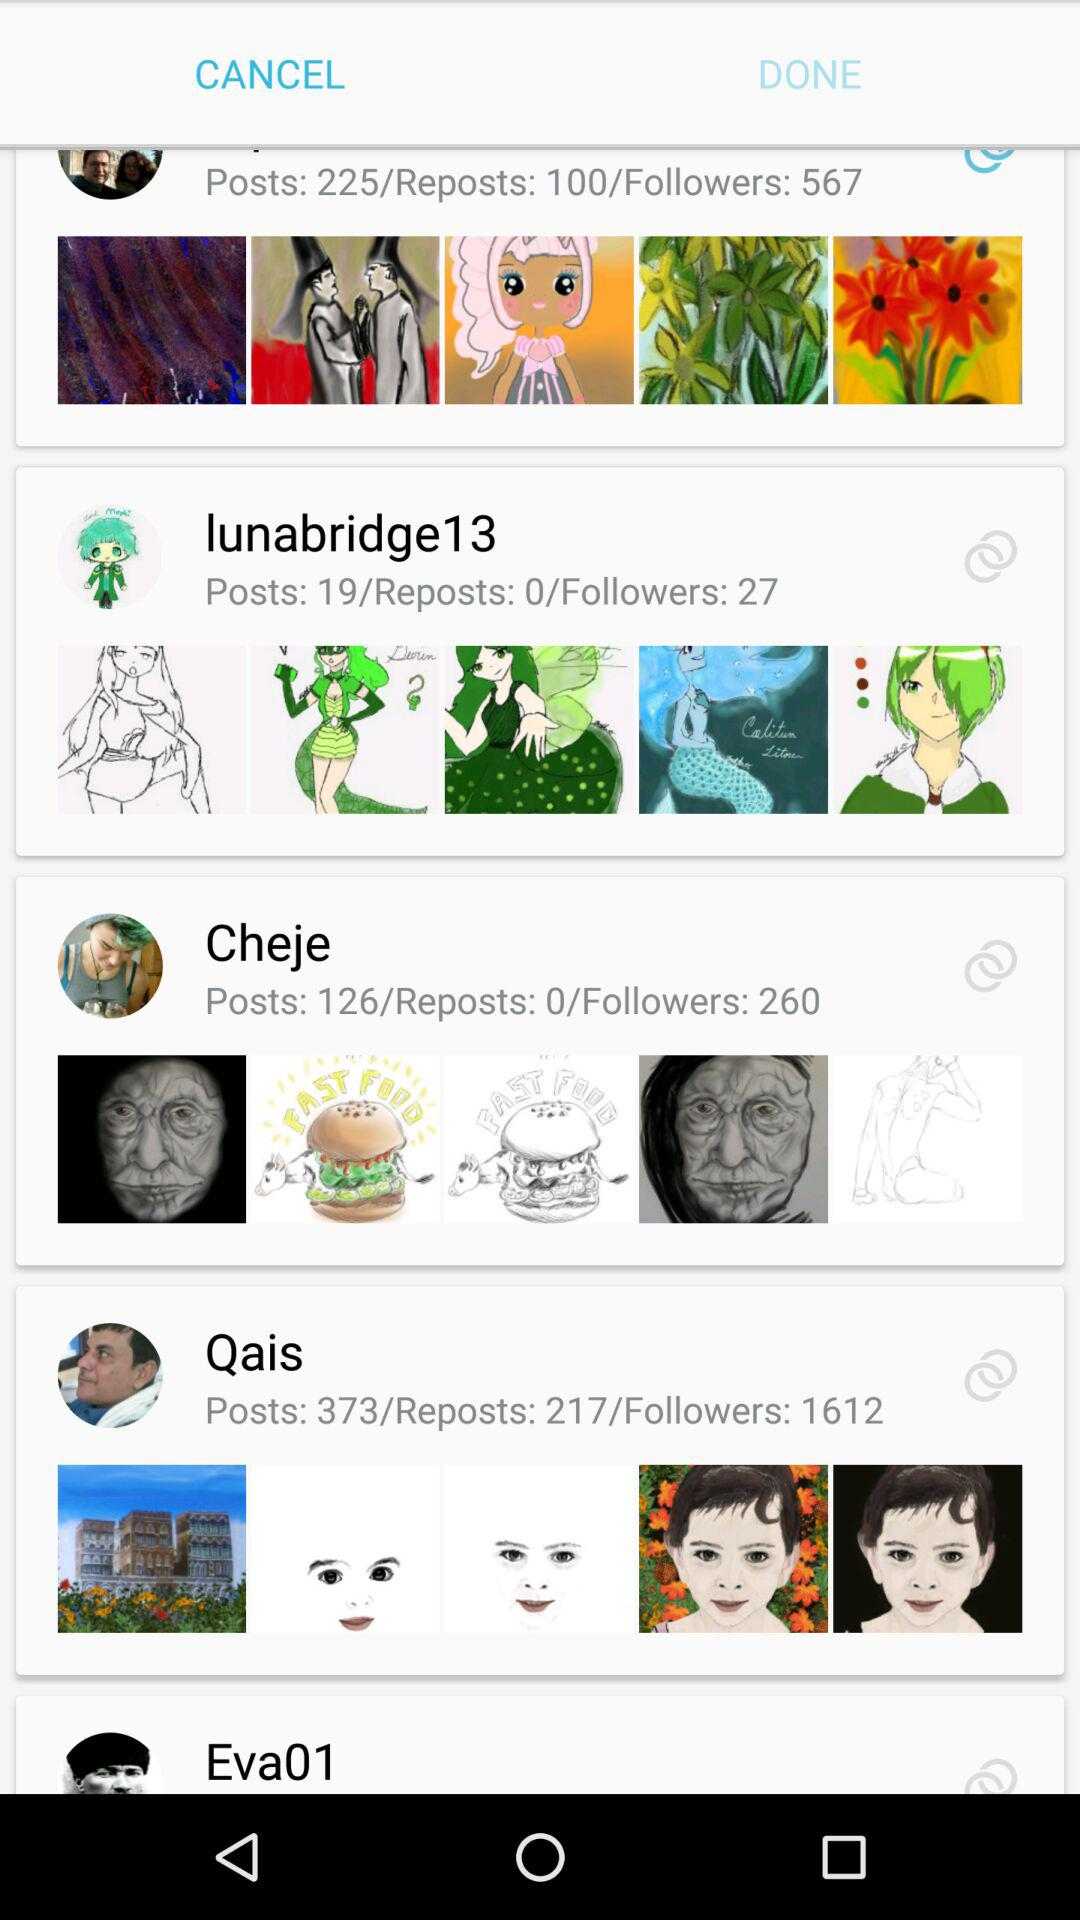How many more followers does Qais have than Cheje?
Answer the question using a single word or phrase. 1352 